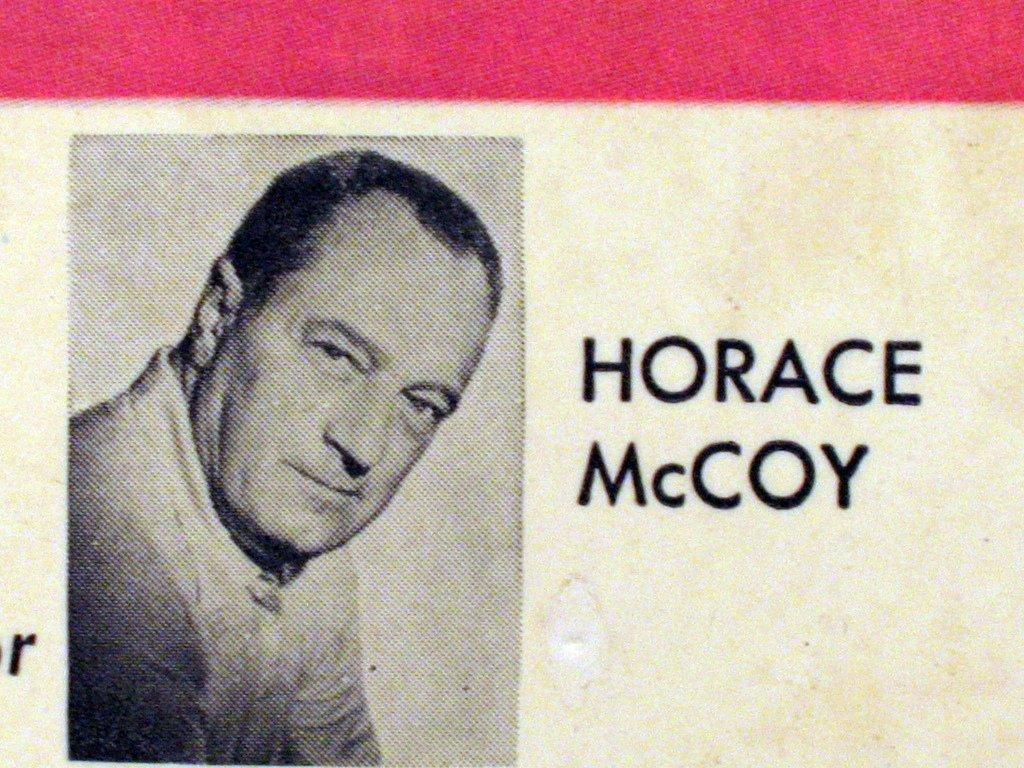What is the main subject of the image? The main subject of the image is a person's photo. Can you describe any additional details about the photo? Yes, there is writing on the photo. Can you see any evidence of a plough in the image? There is no plough present in the image; it features a person's photo with writing on it. 